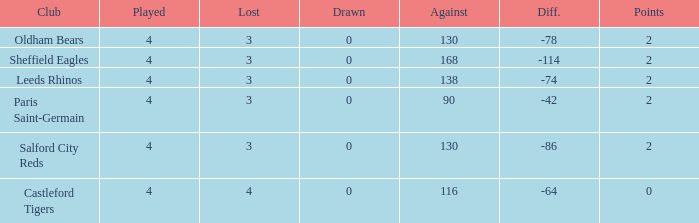What is the sum of losses for teams with less than 4 games played? None. 